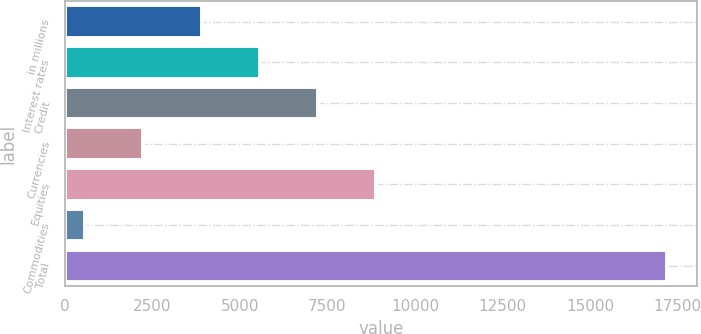<chart> <loc_0><loc_0><loc_500><loc_500><bar_chart><fcel>in millions<fcel>Interest rates<fcel>Credit<fcel>Currencies<fcel>Equities<fcel>Commodities<fcel>Total<nl><fcel>3902.6<fcel>5566.4<fcel>7230.2<fcel>2238.8<fcel>8894<fcel>575<fcel>17213<nl></chart> 